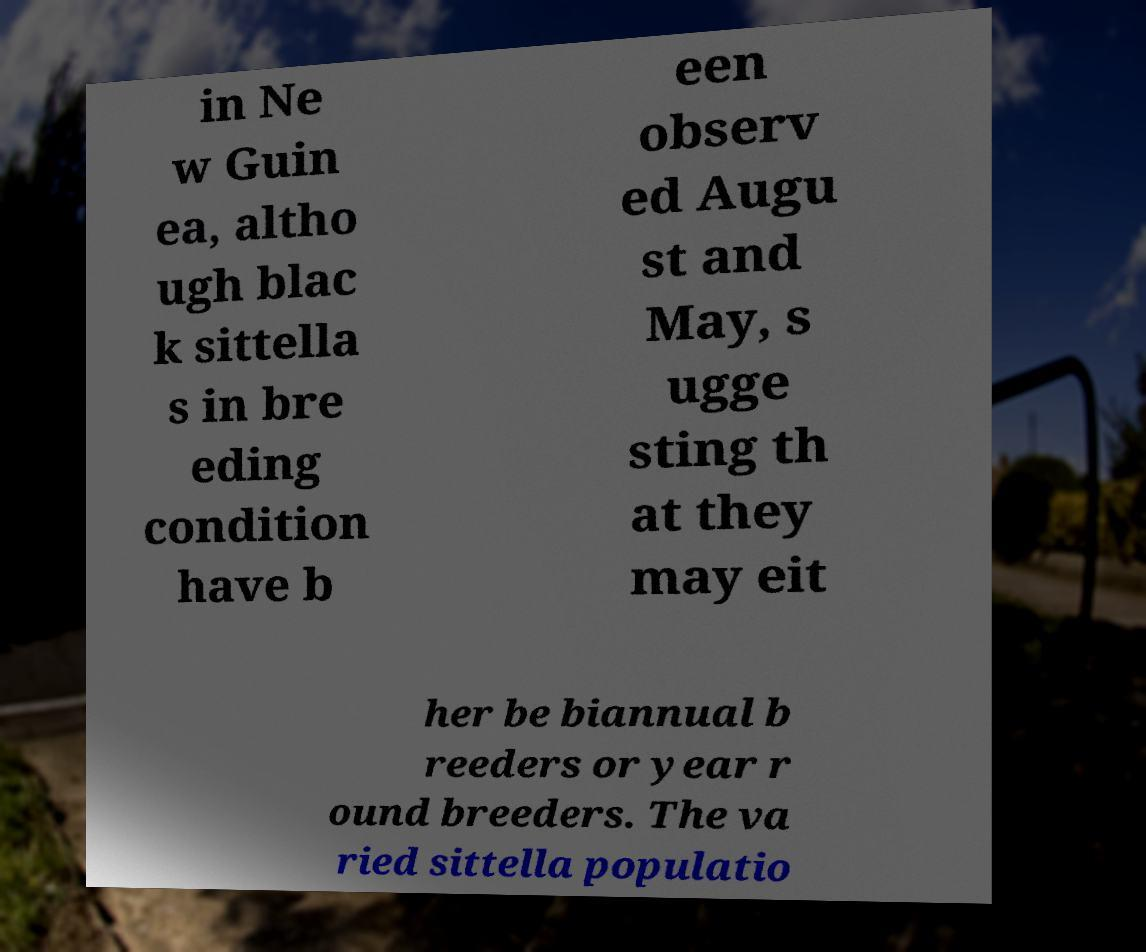Can you read and provide the text displayed in the image?This photo seems to have some interesting text. Can you extract and type it out for me? in Ne w Guin ea, altho ugh blac k sittella s in bre eding condition have b een observ ed Augu st and May, s ugge sting th at they may eit her be biannual b reeders or year r ound breeders. The va ried sittella populatio 